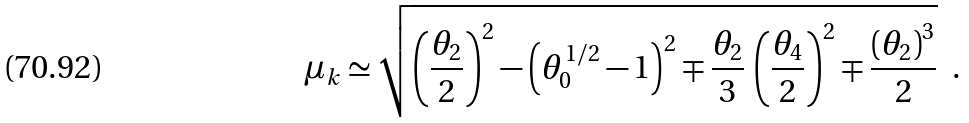Convert formula to latex. <formula><loc_0><loc_0><loc_500><loc_500>\mu _ { k } \simeq \sqrt { \left ( \frac { \theta _ { 2 } } { 2 } \right ) ^ { 2 } - \left ( \theta _ { 0 } ^ { 1 / 2 } - 1 \right ) ^ { 2 } \mp \frac { \theta _ { 2 } } { 3 } \, \left ( \frac { \theta _ { 4 } } { 2 } \right ) ^ { 2 } \mp \frac { \left ( \theta _ { 2 } \right ) ^ { 3 } } { 2 } } \ \ .</formula> 